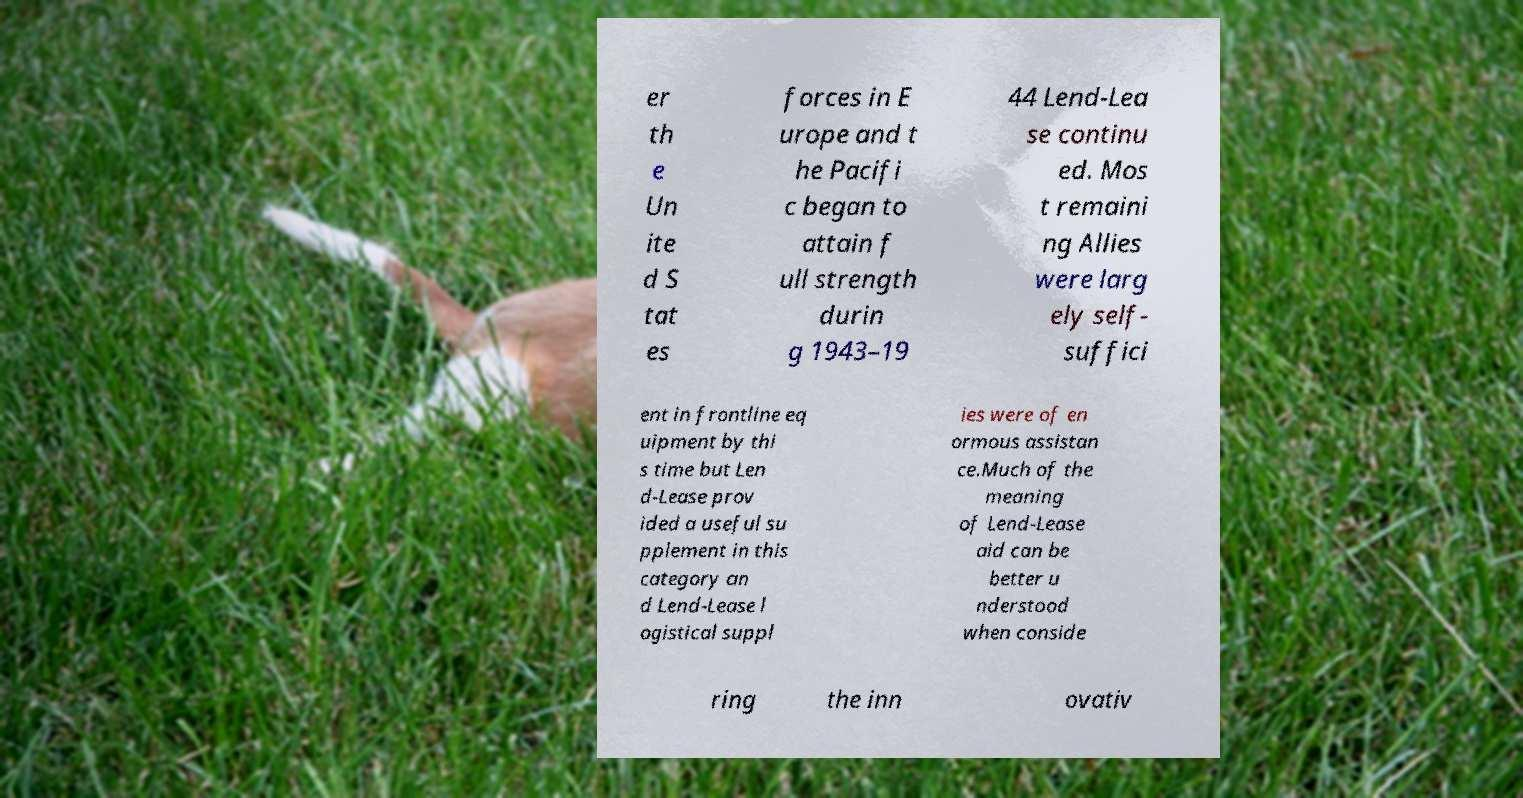For documentation purposes, I need the text within this image transcribed. Could you provide that? er th e Un ite d S tat es forces in E urope and t he Pacifi c began to attain f ull strength durin g 1943–19 44 Lend-Lea se continu ed. Mos t remaini ng Allies were larg ely self- suffici ent in frontline eq uipment by thi s time but Len d-Lease prov ided a useful su pplement in this category an d Lend-Lease l ogistical suppl ies were of en ormous assistan ce.Much of the meaning of Lend-Lease aid can be better u nderstood when conside ring the inn ovativ 